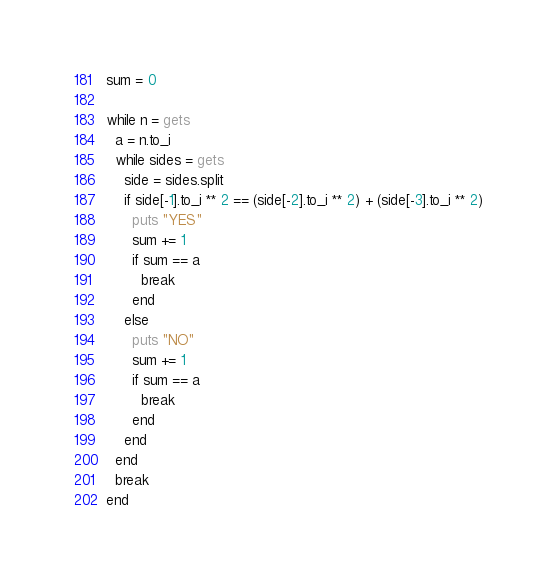Convert code to text. <code><loc_0><loc_0><loc_500><loc_500><_Ruby_>sum = 0

while n = gets
  a = n.to_i
  while sides = gets
    side = sides.split
    if side[-1].to_i ** 2 == (side[-2].to_i ** 2) + (side[-3].to_i ** 2)
      puts "YES"
      sum += 1
      if sum == a
        break
      end
    else
      puts "NO"
      sum += 1
      if sum == a
        break
      end
    end
  end
  break
end</code> 